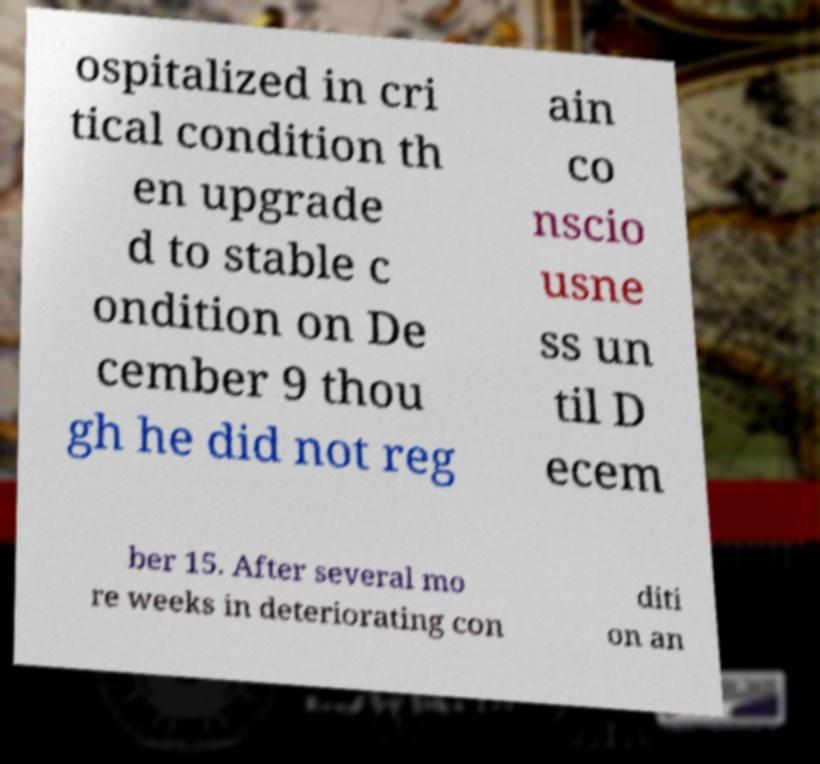Can you accurately transcribe the text from the provided image for me? ospitalized in cri tical condition th en upgrade d to stable c ondition on De cember 9 thou gh he did not reg ain co nscio usne ss un til D ecem ber 15. After several mo re weeks in deteriorating con diti on an 